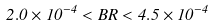<formula> <loc_0><loc_0><loc_500><loc_500>2 . 0 \times 1 0 ^ { - 4 } < B R < 4 . 5 \times 1 0 ^ { - 4 }</formula> 